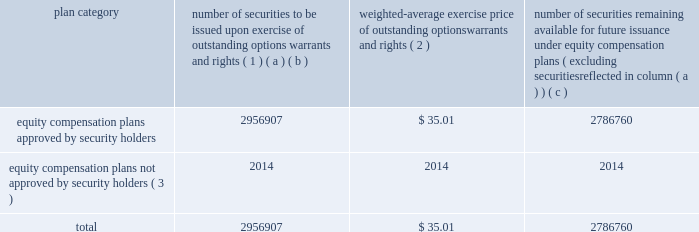Equity compensation plan information the table presents the equity securities available for issuance under our equity compensation plans as of december 31 , 2013 .
Equity compensation plan information plan category number of securities to be issued upon exercise of outstanding options , warrants and rights ( 1 ) weighted-average exercise price of outstanding options , warrants and rights ( 2 ) number of securities remaining available for future issuance under equity compensation plans ( excluding securities reflected in column ( a ) ) ( a ) ( b ) ( c ) equity compensation plans approved by security holders 2956907 $ 35.01 2786760 equity compensation plans not approved by security holders ( 3 ) 2014 2014 2014 .
( 1 ) includes grants made under the huntington ingalls industries , inc .
2012 long-term incentive stock plan ( the "2012 plan" ) , which was approved by our stockholders on may 2 , 2012 , and the huntington ingalls industries , inc .
2011 long-term incentive stock plan ( the "2011 plan" ) , which was approved by the sole stockholder of hii prior to its spin-off from northrop grumman corporation .
Of these shares , 818723 were subject to stock options , 1002217 were subject to outstanding restricted performance stock rights , 602400 were restricted stock rights , and 63022 were stock rights granted under the 2011 plan .
In addition , this number includes 24428 stock rights and 446117 restricted performance stock rights granted under the 2012 plan , assuming target performance achievement .
( 2 ) this is the weighted average exercise price of the 818723 outstanding stock options only .
( 3 ) there are no awards made under plans not approved by security holders .
Item 13 .
Certain relationships and related transactions , and director independence information as to certain relationships and related transactions and director independence will be incorporated herein by reference to the proxy statement for our 2014 annual meeting of stockholders to be filed within 120 days after the end of the company 2019s fiscal year .
Item 14 .
Principal accountant fees and services information as to principal accountant fees and services will be incorporated herein by reference to the proxy statement for our 2014 annual meeting of stockholders to be filed within 120 days after the end of the company 2019s fiscal year. .
What portion of the equity compensation plan approved by security holders is to be issued upon the exercise of the outstanding options warrants and rights? 
Computations: (2956907 / (2956907 + 2786760))
Answer: 0.51481. Equity compensation plan information the table presents the equity securities available for issuance under our equity compensation plans as of december 31 , 2013 .
Equity compensation plan information plan category number of securities to be issued upon exercise of outstanding options , warrants and rights ( 1 ) weighted-average exercise price of outstanding options , warrants and rights ( 2 ) number of securities remaining available for future issuance under equity compensation plans ( excluding securities reflected in column ( a ) ) ( a ) ( b ) ( c ) equity compensation plans approved by security holders 2956907 $ 35.01 2786760 equity compensation plans not approved by security holders ( 3 ) 2014 2014 2014 .
( 1 ) includes grants made under the huntington ingalls industries , inc .
2012 long-term incentive stock plan ( the "2012 plan" ) , which was approved by our stockholders on may 2 , 2012 , and the huntington ingalls industries , inc .
2011 long-term incentive stock plan ( the "2011 plan" ) , which was approved by the sole stockholder of hii prior to its spin-off from northrop grumman corporation .
Of these shares , 818723 were subject to stock options , 1002217 were subject to outstanding restricted performance stock rights , 602400 were restricted stock rights , and 63022 were stock rights granted under the 2011 plan .
In addition , this number includes 24428 stock rights and 446117 restricted performance stock rights granted under the 2012 plan , assuming target performance achievement .
( 2 ) this is the weighted average exercise price of the 818723 outstanding stock options only .
( 3 ) there are no awards made under plans not approved by security holders .
Item 13 .
Certain relationships and related transactions , and director independence information as to certain relationships and related transactions and director independence will be incorporated herein by reference to the proxy statement for our 2014 annual meeting of stockholders to be filed within 120 days after the end of the company 2019s fiscal year .
Item 14 .
Principal accountant fees and services information as to principal accountant fees and services will be incorporated herein by reference to the proxy statement for our 2014 annual meeting of stockholders to be filed within 120 days after the end of the company 2019s fiscal year. .
What is the combined number of equity compensation plans approved by security holders? 
Rationale: the combined amount is the sum of both security types
Computations: (2956907 + 2786760)
Answer: 5743667.0. 